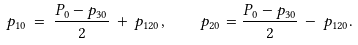<formula> <loc_0><loc_0><loc_500><loc_500>p _ { 1 0 } \, = \, { \frac { P _ { 0 } - p _ { 3 0 } } { 2 } } \, + \, p _ { 1 2 0 } , \quad p _ { 2 0 } = { \frac { P _ { 0 } - p _ { 3 0 } } { 2 } } \, - \, p _ { 1 2 0 } .</formula> 